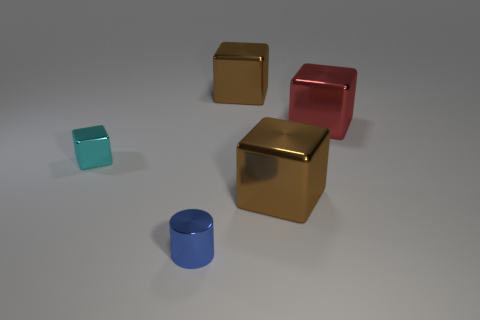There is another small object that is the same shape as the red object; what material is it?
Your answer should be compact. Metal. What number of brown objects are in front of the tiny metallic block?
Your response must be concise. 1. Are there any brown shiny objects that are on the left side of the tiny metal object behind the blue cylinder that is in front of the red thing?
Offer a terse response. No. Is the size of the blue cylinder the same as the red metallic block?
Your response must be concise. No. Are there an equal number of objects that are on the left side of the red thing and shiny things to the right of the tiny cube?
Provide a succinct answer. Yes. There is a small object behind the cylinder; what shape is it?
Your response must be concise. Cube. There is a blue thing that is the same size as the cyan cube; what is its shape?
Provide a succinct answer. Cylinder. What color is the large metallic block to the right of the brown shiny object that is on the right side of the brown thing behind the large red shiny thing?
Give a very brief answer. Red. Do the small cyan metal thing and the large red metallic object have the same shape?
Your response must be concise. Yes. Is the number of large brown metallic cubes that are left of the tiny blue thing the same as the number of tiny green cylinders?
Make the answer very short. Yes. 